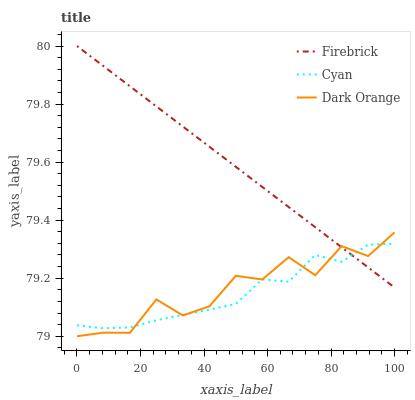Does Cyan have the minimum area under the curve?
Answer yes or no. Yes. Does Firebrick have the maximum area under the curve?
Answer yes or no. Yes. Does Dark Orange have the minimum area under the curve?
Answer yes or no. No. Does Dark Orange have the maximum area under the curve?
Answer yes or no. No. Is Firebrick the smoothest?
Answer yes or no. Yes. Is Dark Orange the roughest?
Answer yes or no. Yes. Is Dark Orange the smoothest?
Answer yes or no. No. Is Firebrick the roughest?
Answer yes or no. No. Does Dark Orange have the lowest value?
Answer yes or no. Yes. Does Firebrick have the lowest value?
Answer yes or no. No. Does Firebrick have the highest value?
Answer yes or no. Yes. Does Dark Orange have the highest value?
Answer yes or no. No. Does Dark Orange intersect Cyan?
Answer yes or no. Yes. Is Dark Orange less than Cyan?
Answer yes or no. No. Is Dark Orange greater than Cyan?
Answer yes or no. No. 